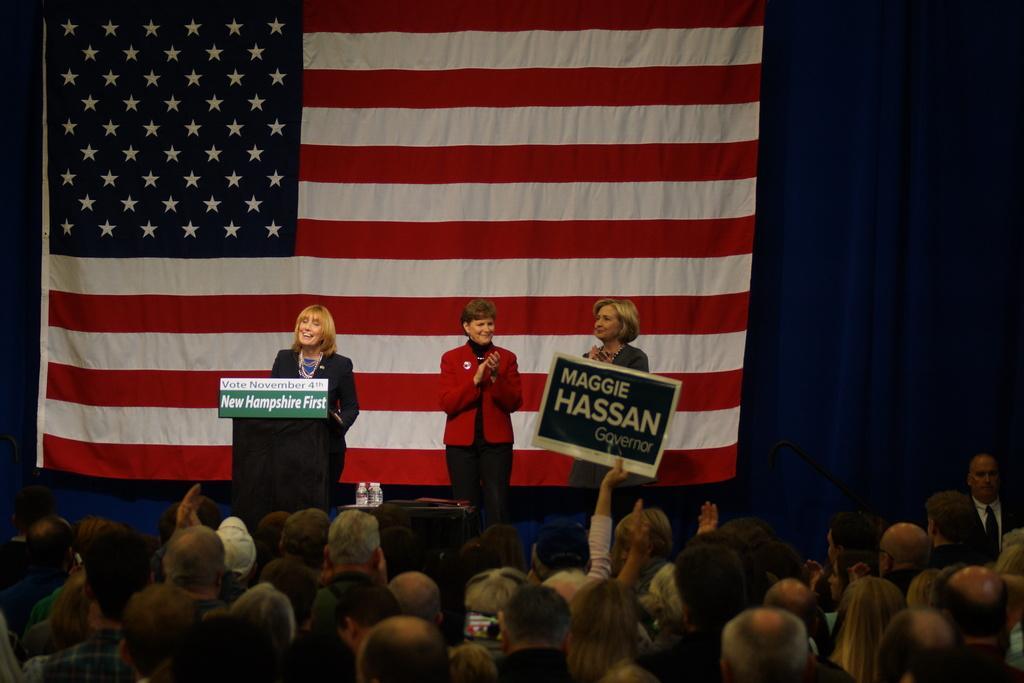Could you give a brief overview of what you see in this image? In this image in front there are people. There is a person holding the placard. There is a table. On top of it there are water bottles. There is a person standing in front of the dais. On top of the days there is a name board. Beside the days there are two people clapping. In the background of the image there is a flag. There are curtains. 